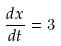<formula> <loc_0><loc_0><loc_500><loc_500>\frac { d x } { d t } = 3</formula> 